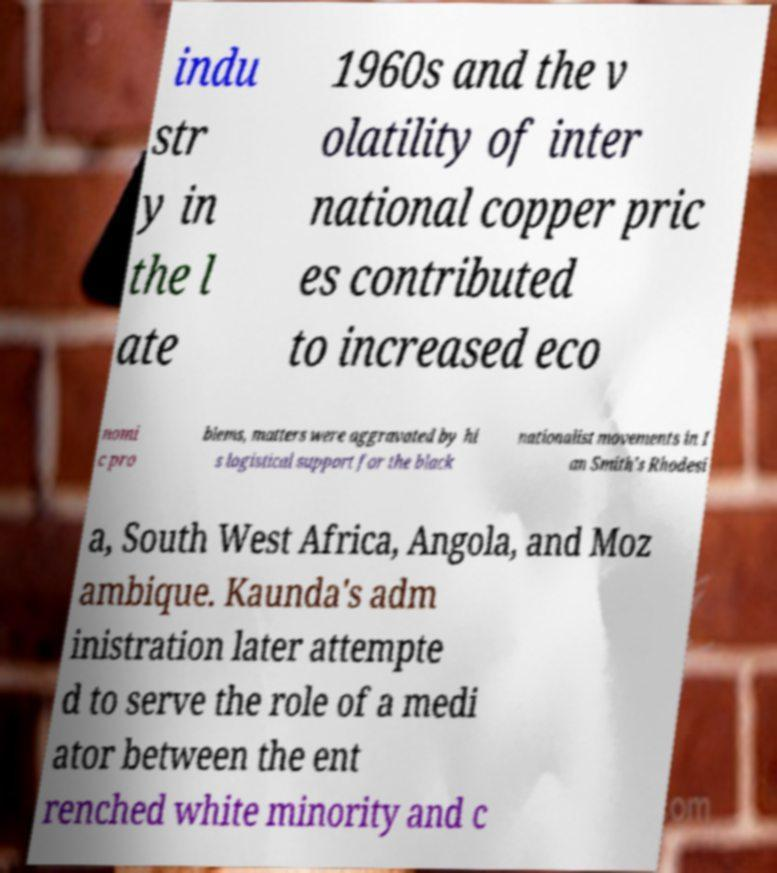Please identify and transcribe the text found in this image. indu str y in the l ate 1960s and the v olatility of inter national copper pric es contributed to increased eco nomi c pro blems, matters were aggravated by hi s logistical support for the black nationalist movements in I an Smith's Rhodesi a, South West Africa, Angola, and Moz ambique. Kaunda's adm inistration later attempte d to serve the role of a medi ator between the ent renched white minority and c 